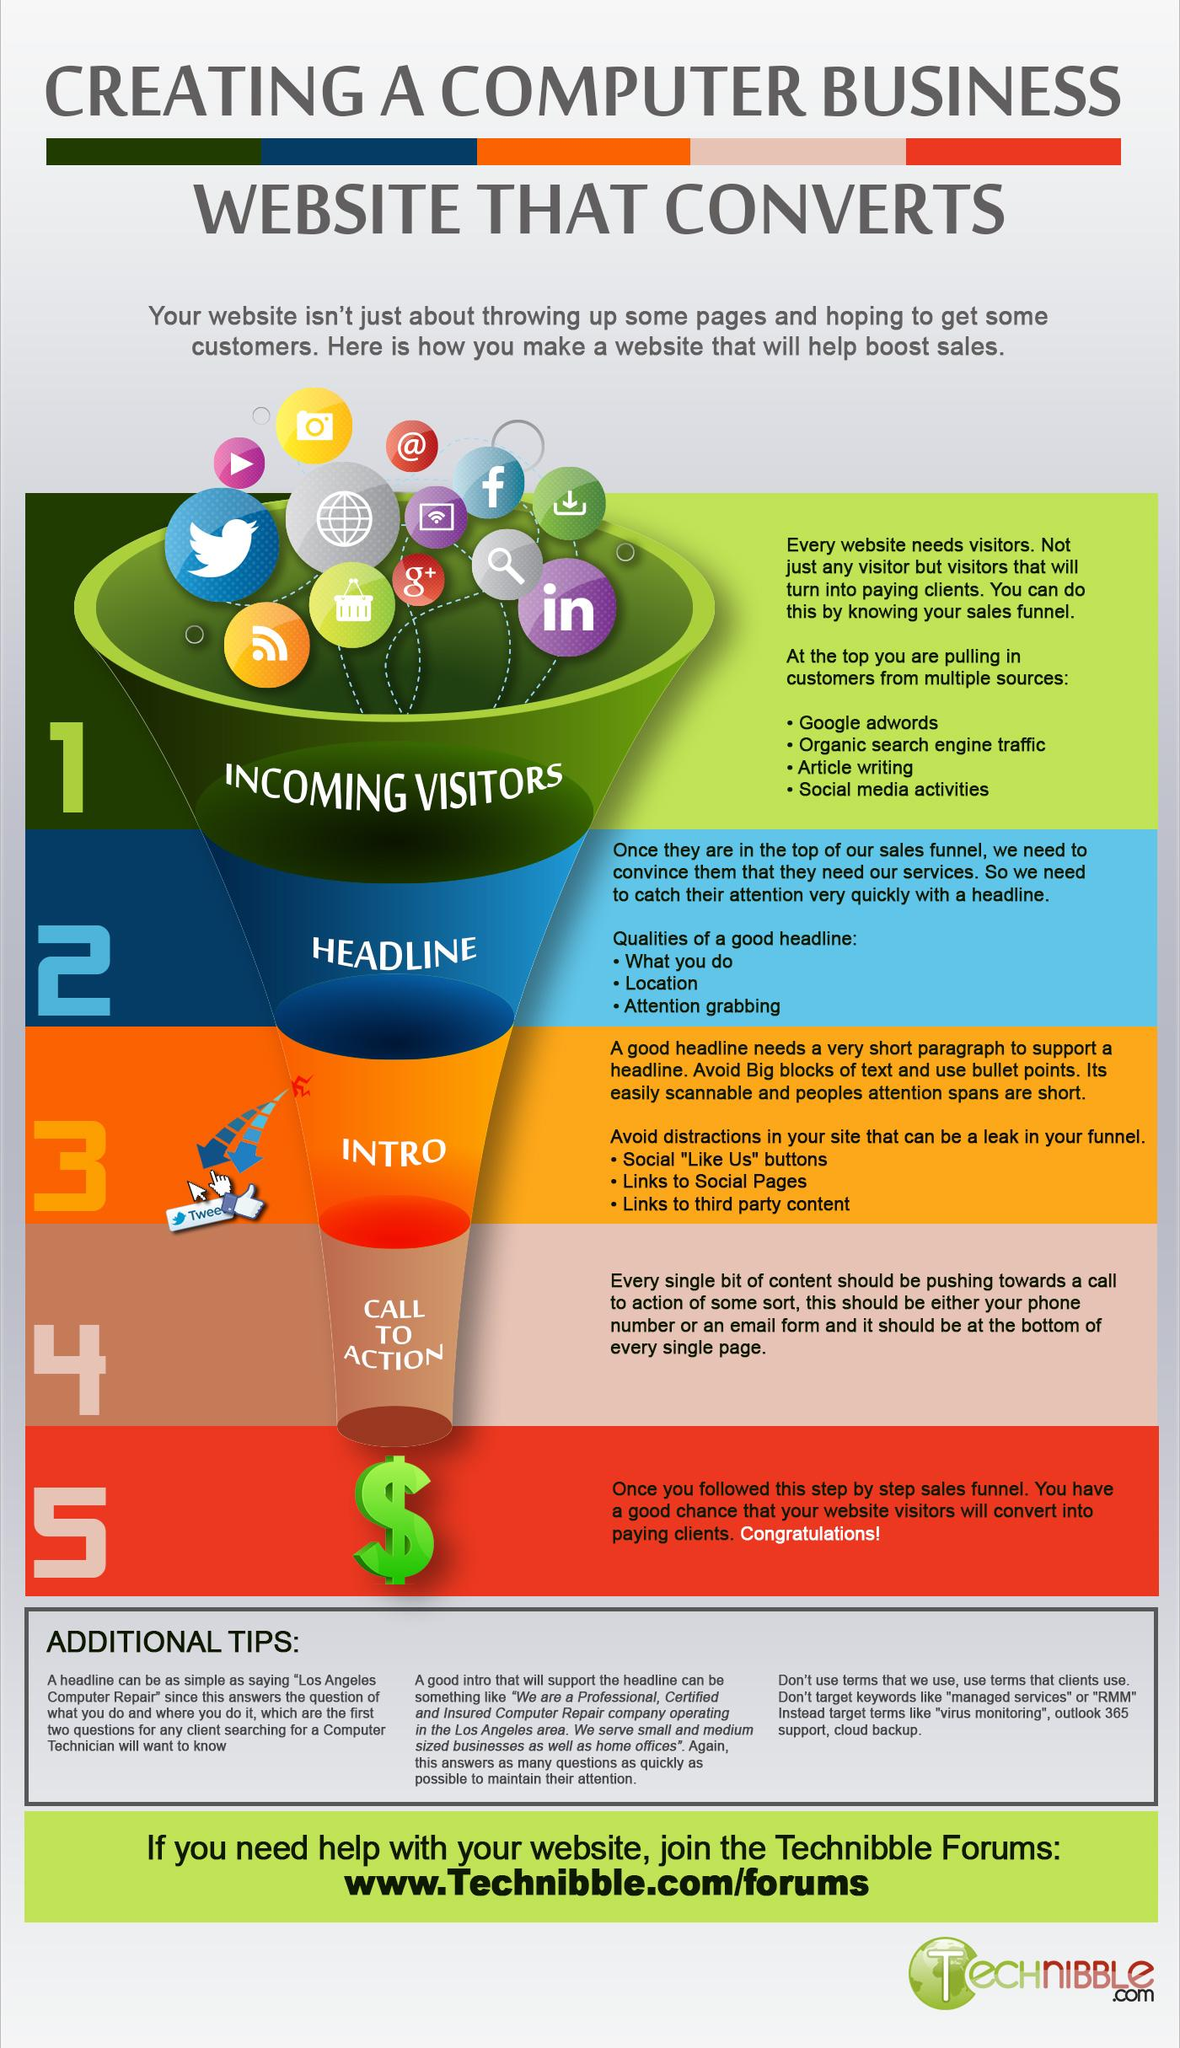Highlight a few significant elements in this photo. This infographic contains one download icon. There is one search icon in this infographic. The color of the dollar sign is green. The total number of icons in this infographic is 13. The second quality of an effective headline is its location. 